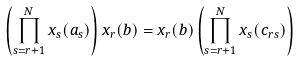<formula> <loc_0><loc_0><loc_500><loc_500>\left ( \prod _ { s = r + 1 } ^ { N } x _ { s } ( a _ { s } ) \right ) x _ { r } ( b ) & = x _ { r } ( b ) \left ( \prod _ { s = r + 1 } ^ { N } x _ { s } ( c _ { r s } ) \right )</formula> 